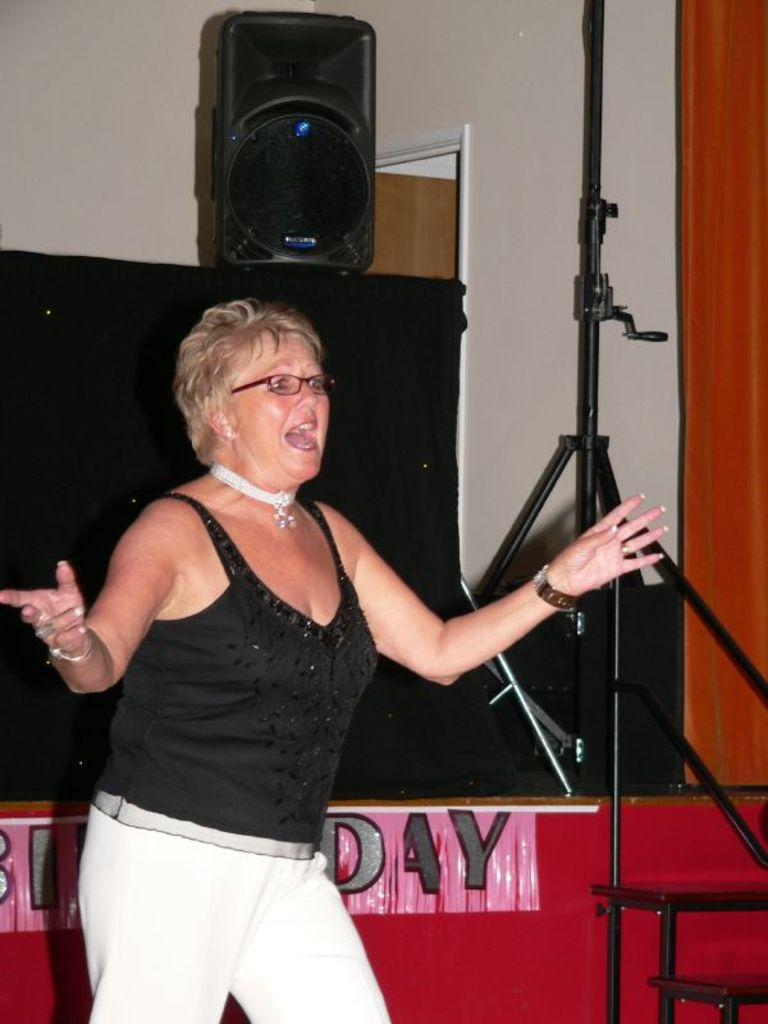Provide a one-sentence caption for the provided image. A woman singing in front of a birthday sign. 